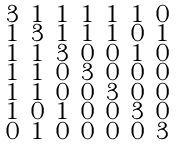<formula> <loc_0><loc_0><loc_500><loc_500>\begin{smallmatrix} 3 & 1 & 1 & 1 & 1 & 1 & 0 \\ 1 & 3 & 1 & 1 & 1 & 0 & 1 \\ 1 & 1 & 3 & 0 & 0 & 1 & 0 \\ 1 & 1 & 0 & 3 & 0 & 0 & 0 \\ 1 & 1 & 0 & 0 & 3 & 0 & 0 \\ 1 & 0 & 1 & 0 & 0 & 3 & 0 \\ 0 & 1 & 0 & 0 & 0 & 0 & 3 \end{smallmatrix}</formula> 